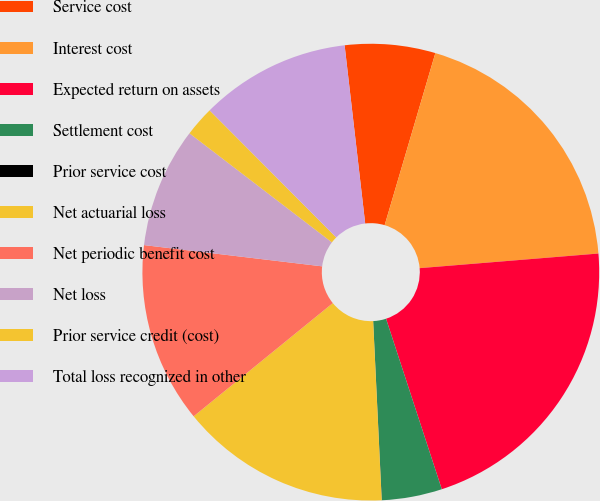<chart> <loc_0><loc_0><loc_500><loc_500><pie_chart><fcel>Service cost<fcel>Interest cost<fcel>Expected return on assets<fcel>Settlement cost<fcel>Prior service cost<fcel>Net actuarial loss<fcel>Net periodic benefit cost<fcel>Net loss<fcel>Prior service credit (cost)<fcel>Total loss recognized in other<nl><fcel>6.39%<fcel>19.14%<fcel>21.27%<fcel>4.26%<fcel>0.01%<fcel>14.89%<fcel>12.76%<fcel>8.51%<fcel>2.13%<fcel>10.64%<nl></chart> 